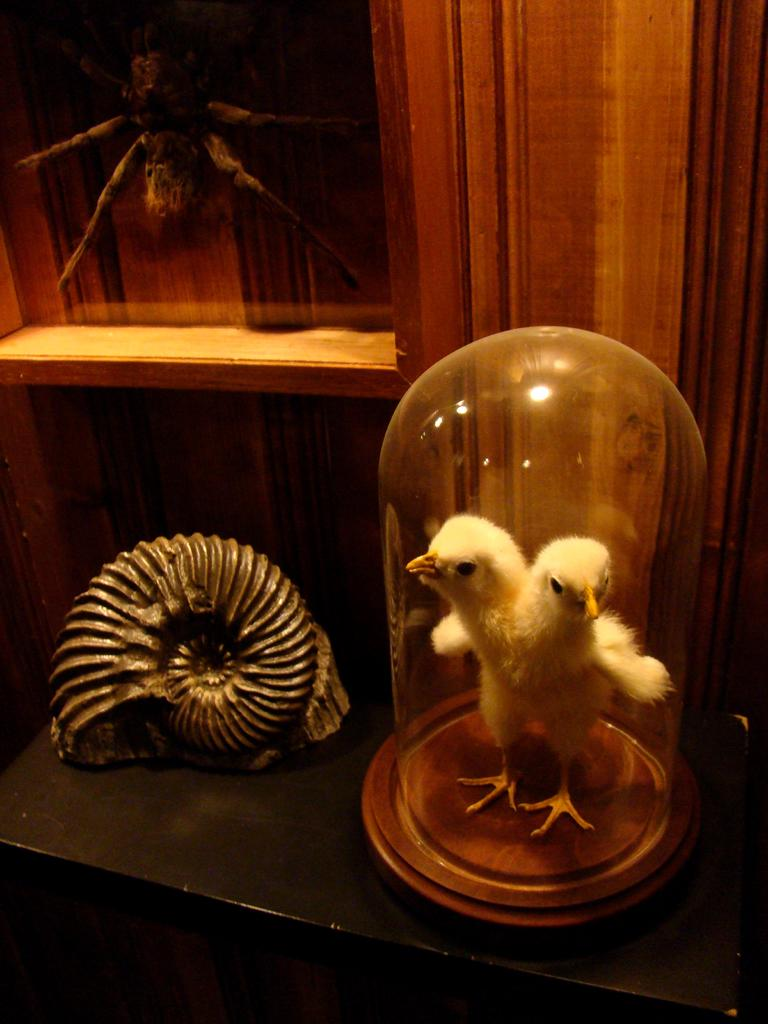What can be seen on the shelf in the image? There is a bird with two heads inside a glass on the shelf. Are there any other objects or creatures on the shelf? Yes, there is a spider in the image. What type of decorative item is present on the shelf? There is a decorative item that resembles a shell in the image. Is there a fan in the image that is helping to cool down the library? There is no fan or library present in the image; it features a shelf with a bird, a spider, and a decorative shell. 